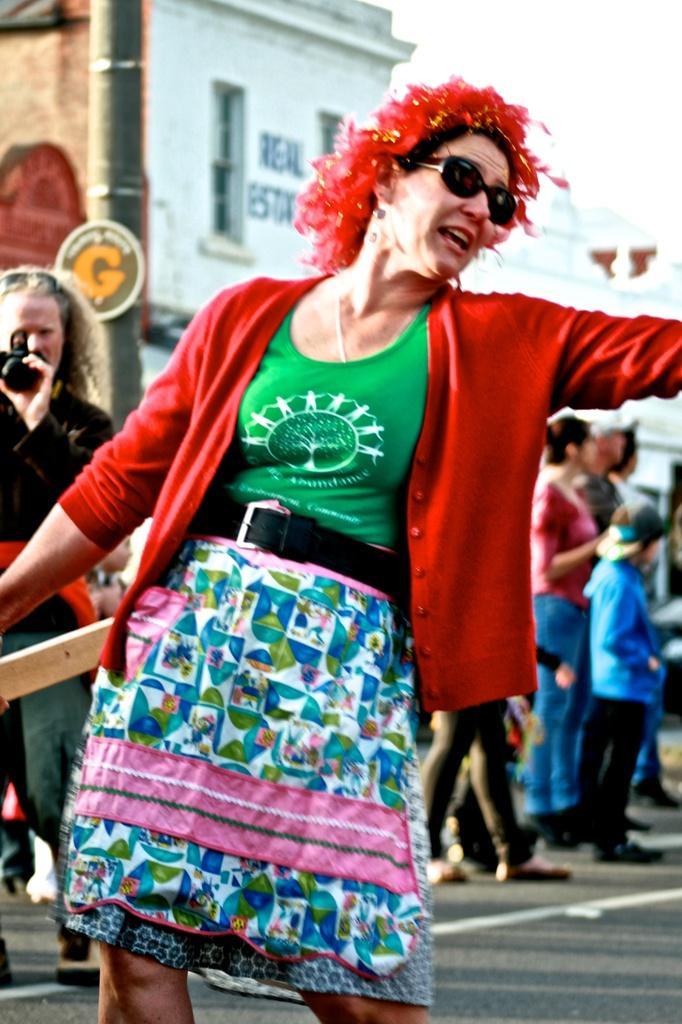Could you give a brief overview of what you see in this image? In this image I can see a road and on it I can see number of people are standing. In the front I can see a woman is wearing red colour jacket, red hair wig, green top, black belt and black shades. On the left side of the image I can see one person is holding a camera and in the background I can see few buildings and I can also see something is written on one building. 